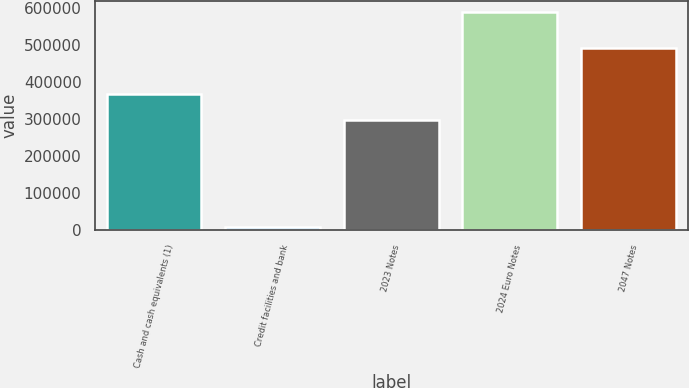Convert chart. <chart><loc_0><loc_0><loc_500><loc_500><bar_chart><fcel>Cash and cash equivalents (1)<fcel>Credit facilities and bank<fcel>2023 Notes<fcel>2024 Euro Notes<fcel>2047 Notes<nl><fcel>368046<fcel>7993<fcel>298670<fcel>589848<fcel>492819<nl></chart> 